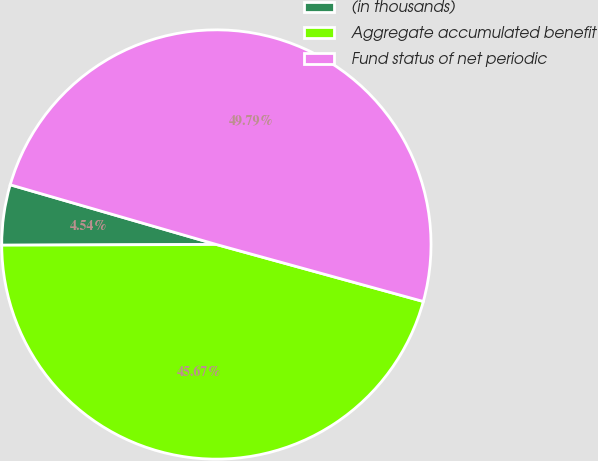Convert chart to OTSL. <chart><loc_0><loc_0><loc_500><loc_500><pie_chart><fcel>(in thousands)<fcel>Aggregate accumulated benefit<fcel>Fund status of net periodic<nl><fcel>4.54%<fcel>45.67%<fcel>49.79%<nl></chart> 